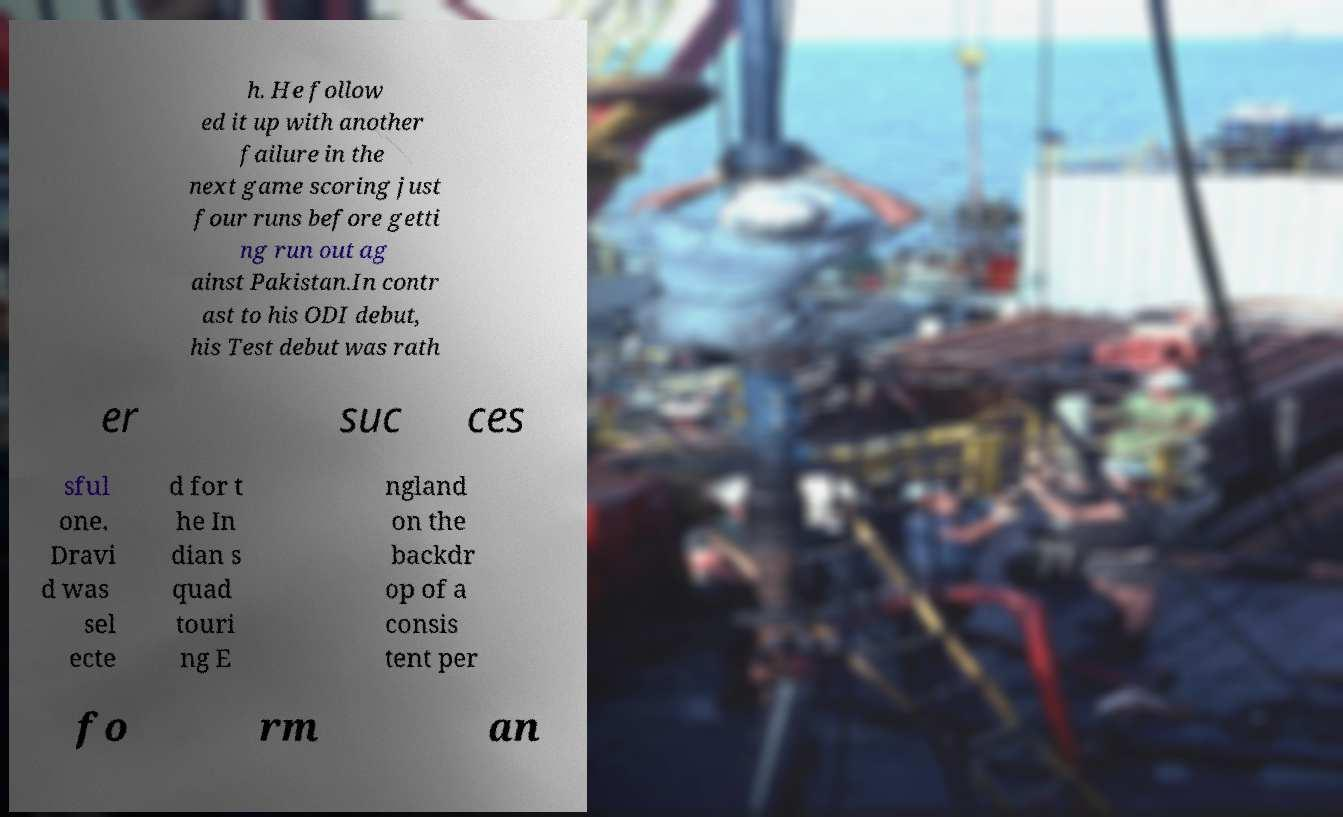Can you read and provide the text displayed in the image?This photo seems to have some interesting text. Can you extract and type it out for me? h. He follow ed it up with another failure in the next game scoring just four runs before getti ng run out ag ainst Pakistan.In contr ast to his ODI debut, his Test debut was rath er suc ces sful one. Dravi d was sel ecte d for t he In dian s quad touri ng E ngland on the backdr op of a consis tent per fo rm an 